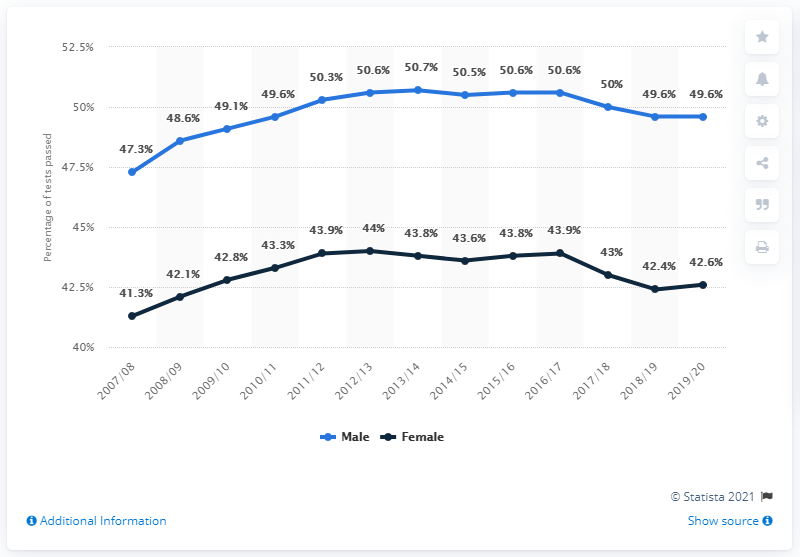Point out several critical features in this image. The lowest decrease after one year was 0.2%. The highest percentage on the black line was 44%. 